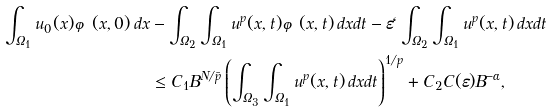Convert formula to latex. <formula><loc_0><loc_0><loc_500><loc_500>\int _ { \Omega _ { 1 } } u _ { 0 } ( x ) \varphi ( x , 0 ) \, d x & - \int _ { \Omega _ { 2 } } \int _ { \Omega _ { 1 } } u ^ { p } ( x , t ) \varphi ( x , t ) \, d x d t - \varepsilon \ell \int _ { \Omega _ { 2 } } \int _ { \Omega _ { 1 } } u ^ { p } ( x , t ) \, d x d t \\ & \leq C _ { 1 } B ^ { N / \bar { p } } \left ( \int _ { \Omega _ { 3 } } \int _ { \Omega _ { 1 } } u ^ { p } ( x , t ) \, d x d t \right ) ^ { 1 / p } + C _ { 2 } C ( \varepsilon ) B ^ { - \alpha } ,</formula> 